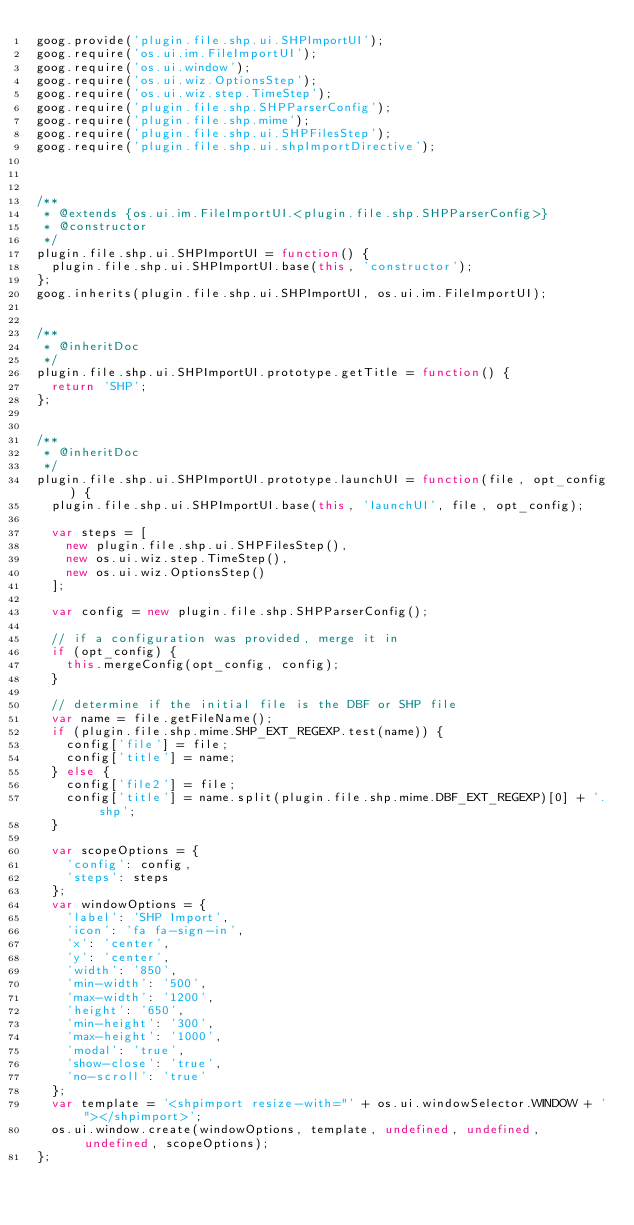Convert code to text. <code><loc_0><loc_0><loc_500><loc_500><_JavaScript_>goog.provide('plugin.file.shp.ui.SHPImportUI');
goog.require('os.ui.im.FileImportUI');
goog.require('os.ui.window');
goog.require('os.ui.wiz.OptionsStep');
goog.require('os.ui.wiz.step.TimeStep');
goog.require('plugin.file.shp.SHPParserConfig');
goog.require('plugin.file.shp.mime');
goog.require('plugin.file.shp.ui.SHPFilesStep');
goog.require('plugin.file.shp.ui.shpImportDirective');



/**
 * @extends {os.ui.im.FileImportUI.<plugin.file.shp.SHPParserConfig>}
 * @constructor
 */
plugin.file.shp.ui.SHPImportUI = function() {
  plugin.file.shp.ui.SHPImportUI.base(this, 'constructor');
};
goog.inherits(plugin.file.shp.ui.SHPImportUI, os.ui.im.FileImportUI);


/**
 * @inheritDoc
 */
plugin.file.shp.ui.SHPImportUI.prototype.getTitle = function() {
  return 'SHP';
};


/**
 * @inheritDoc
 */
plugin.file.shp.ui.SHPImportUI.prototype.launchUI = function(file, opt_config) {
  plugin.file.shp.ui.SHPImportUI.base(this, 'launchUI', file, opt_config);

  var steps = [
    new plugin.file.shp.ui.SHPFilesStep(),
    new os.ui.wiz.step.TimeStep(),
    new os.ui.wiz.OptionsStep()
  ];

  var config = new plugin.file.shp.SHPParserConfig();

  // if a configuration was provided, merge it in
  if (opt_config) {
    this.mergeConfig(opt_config, config);
  }

  // determine if the initial file is the DBF or SHP file
  var name = file.getFileName();
  if (plugin.file.shp.mime.SHP_EXT_REGEXP.test(name)) {
    config['file'] = file;
    config['title'] = name;
  } else {
    config['file2'] = file;
    config['title'] = name.split(plugin.file.shp.mime.DBF_EXT_REGEXP)[0] + '.shp';
  }

  var scopeOptions = {
    'config': config,
    'steps': steps
  };
  var windowOptions = {
    'label': 'SHP Import',
    'icon': 'fa fa-sign-in',
    'x': 'center',
    'y': 'center',
    'width': '850',
    'min-width': '500',
    'max-width': '1200',
    'height': '650',
    'min-height': '300',
    'max-height': '1000',
    'modal': 'true',
    'show-close': 'true',
    'no-scroll': 'true'
  };
  var template = '<shpimport resize-with="' + os.ui.windowSelector.WINDOW + '"></shpimport>';
  os.ui.window.create(windowOptions, template, undefined, undefined, undefined, scopeOptions);
};
</code> 